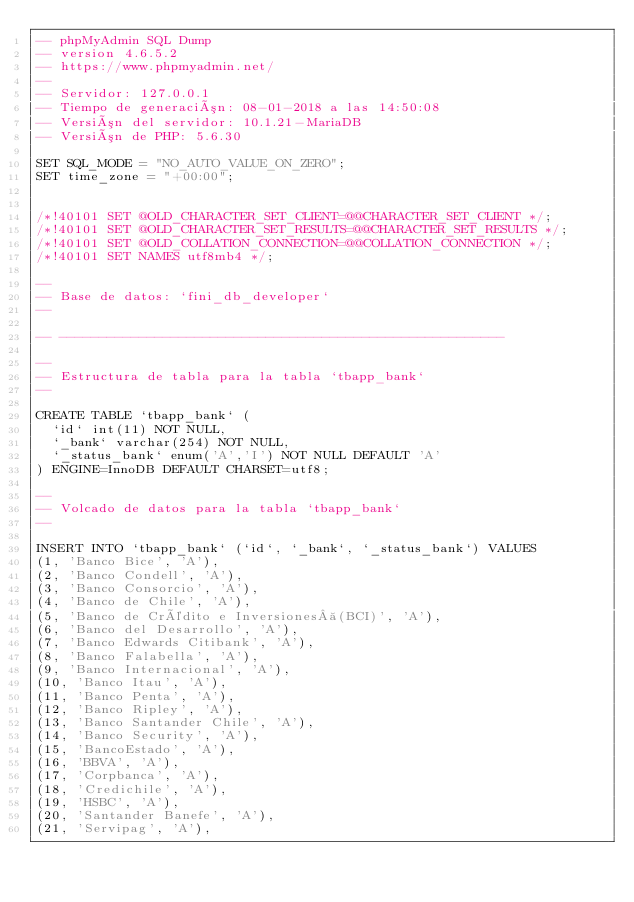Convert code to text. <code><loc_0><loc_0><loc_500><loc_500><_SQL_>-- phpMyAdmin SQL Dump
-- version 4.6.5.2
-- https://www.phpmyadmin.net/
--
-- Servidor: 127.0.0.1
-- Tiempo de generación: 08-01-2018 a las 14:50:08
-- Versión del servidor: 10.1.21-MariaDB
-- Versión de PHP: 5.6.30

SET SQL_MODE = "NO_AUTO_VALUE_ON_ZERO";
SET time_zone = "+00:00";


/*!40101 SET @OLD_CHARACTER_SET_CLIENT=@@CHARACTER_SET_CLIENT */;
/*!40101 SET @OLD_CHARACTER_SET_RESULTS=@@CHARACTER_SET_RESULTS */;
/*!40101 SET @OLD_COLLATION_CONNECTION=@@COLLATION_CONNECTION */;
/*!40101 SET NAMES utf8mb4 */;

--
-- Base de datos: `fini_db_developer`
--

-- --------------------------------------------------------

--
-- Estructura de tabla para la tabla `tbapp_bank`
--

CREATE TABLE `tbapp_bank` (
  `id` int(11) NOT NULL,
  `_bank` varchar(254) NOT NULL,
  `_status_bank` enum('A','I') NOT NULL DEFAULT 'A'
) ENGINE=InnoDB DEFAULT CHARSET=utf8;

--
-- Volcado de datos para la tabla `tbapp_bank`
--

INSERT INTO `tbapp_bank` (`id`, `_bank`, `_status_bank`) VALUES
(1, 'Banco Bice', 'A'),
(2, 'Banco Condell', 'A'),
(3, 'Banco Consorcio', 'A'),
(4, 'Banco de Chile', 'A'),
(5, 'Banco de Crédito e Inversiones (BCI)', 'A'),
(6, 'Banco del Desarrollo', 'A'),
(7, 'Banco Edwards Citibank', 'A'),
(8, 'Banco Falabella', 'A'),
(9, 'Banco Internacional', 'A'),
(10, 'Banco Itau', 'A'),
(11, 'Banco Penta', 'A'),
(12, 'Banco Ripley', 'A'),
(13, 'Banco Santander Chile', 'A'),
(14, 'Banco Security', 'A'),
(15, 'BancoEstado', 'A'),
(16, 'BBVA', 'A'),
(17, 'Corpbanca', 'A'),
(18, 'Credichile', 'A'),
(19, 'HSBC', 'A'),
(20, 'Santander Banefe', 'A'),
(21, 'Servipag', 'A'),</code> 